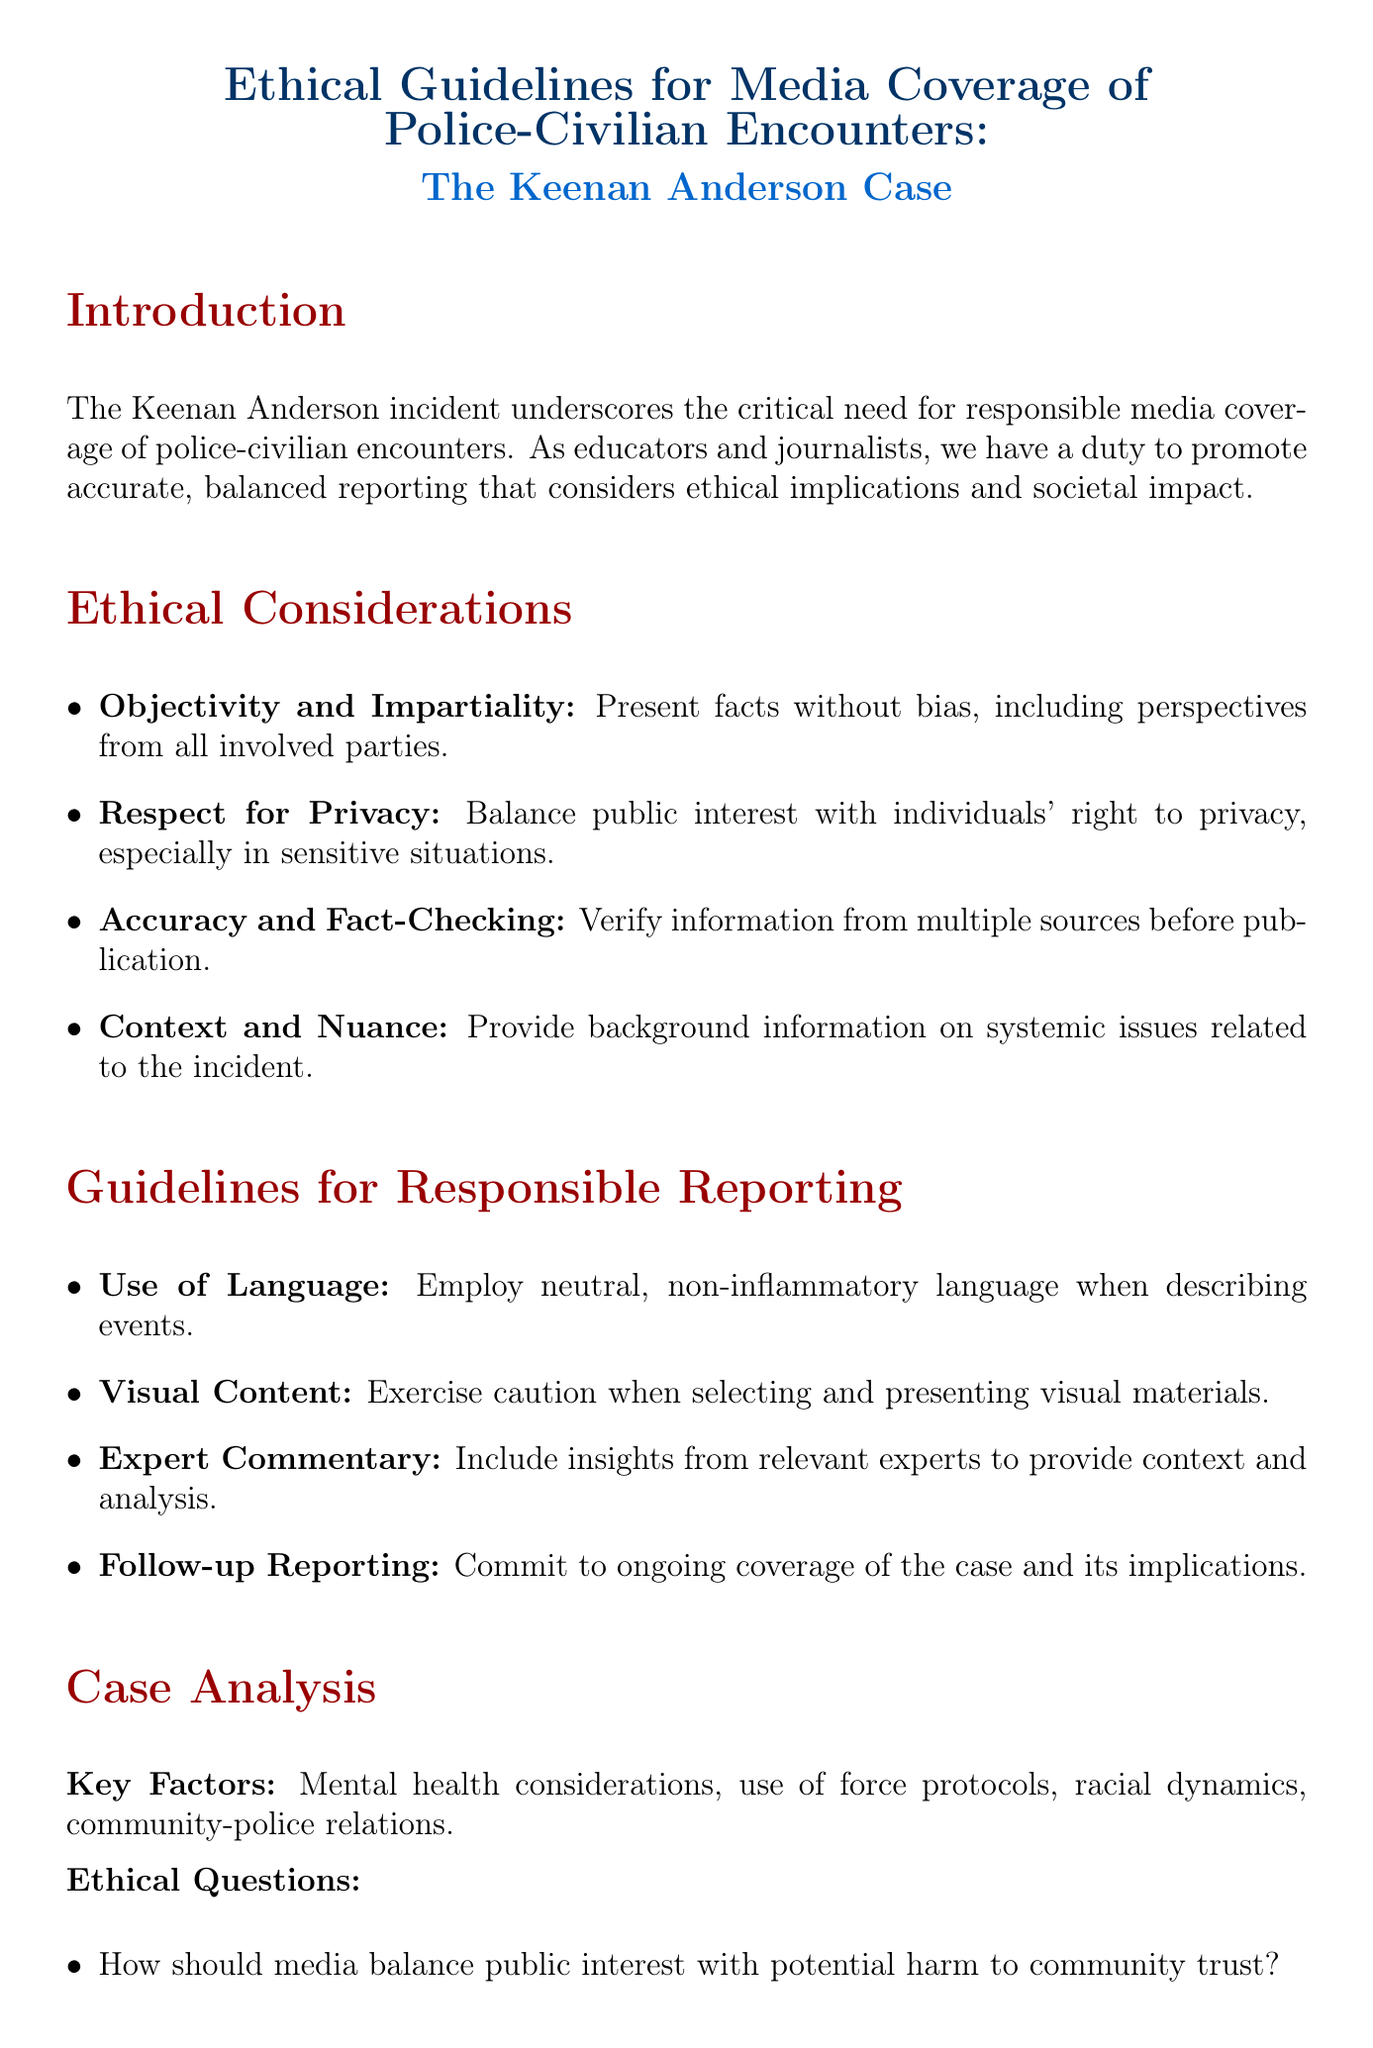what is the title of the memo? The title of the memo is stated at the beginning and encapsulates the main subject matter.
Answer: Ethical Guidelines for Media Coverage of Police-Civilian Encounters: The Keenan Anderson Case what principle emphasizes presenting facts without bias? This principle is listed under ethical considerations and pertains to how information should be reported.
Answer: Objectivity and Impartiality what is one example of respect for privacy in reporting? This example illustrates a specific action that aligns with the principle of privacy.
Answer: Avoid publishing graphic details or images that may cause undue distress to Anderson's family or the public which expert is suggested for commentary on racial disparities in policing? The document highlights an expert in the field who is relevant to the discussion on police practices.
Answer: Dr. Phillip Atiba Goff what is a key factor in the case analysis? This key factor is one of the dimensions considered when analyzing the incident's context.
Answer: Mental health considerations how many ethical questions are presented in the case analysis? The document explicitly lists these questions under the case analysis section.
Answer: Three what is the recommended approach for reporting on the case? This provides guidance on how to frame the analysis of the incident responsibly.
Answer: Adopt a holistic perspective that examines the incident within broader societal contexts what organization is mentioned in the sources for their Code of Ethics? This organization is recognized for setting standards for ethical journalism.
Answer: Society of Professional Journalists 